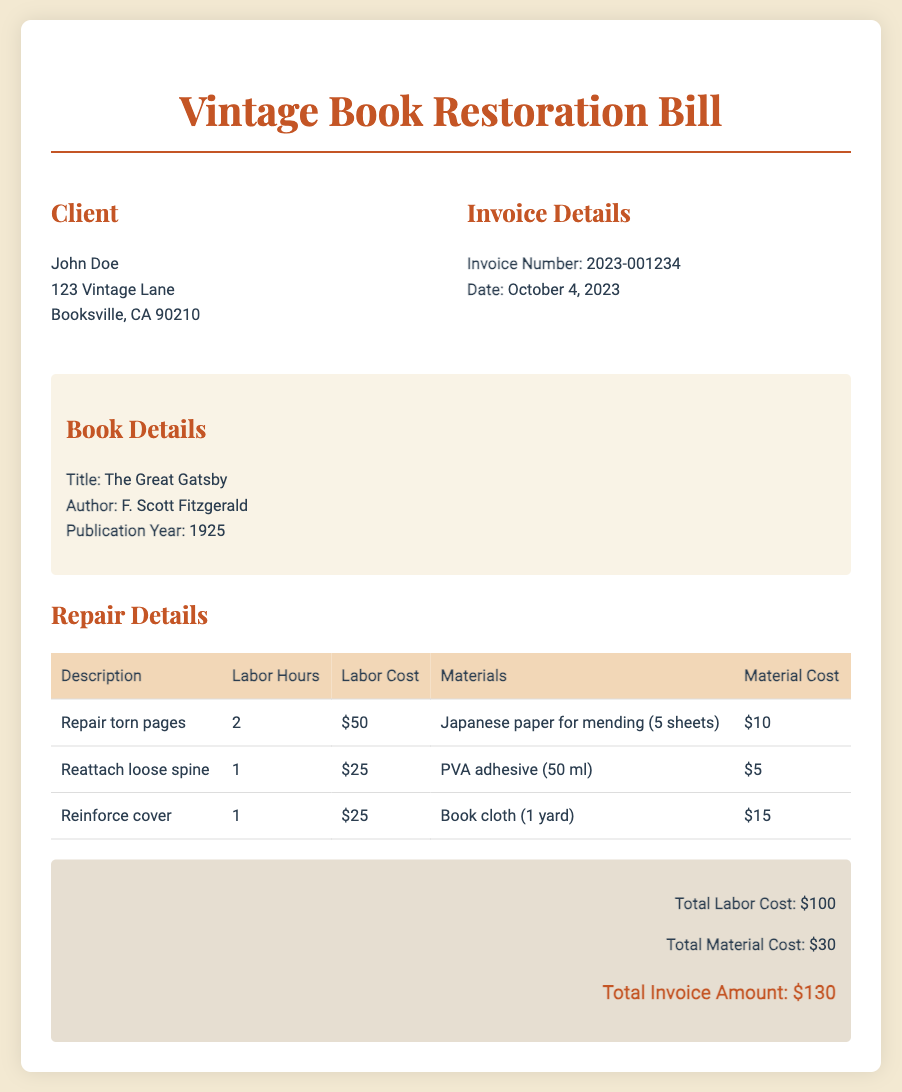What is the client's name? The client's name is provided in the client information section.
Answer: John Doe What is the invoice number? The invoice number can be found under the invoice details section.
Answer: 2023-001234 What is the publication year of the book? The publication year of the book is stated in the book details section.
Answer: 1925 How many labor hours were spent on repairing torn pages? The labor hours for repairing torn pages are listed in the repair details table.
Answer: 2 What is the material cost for reattaching the loose spine? The material cost for reattaching the loose spine is specified in the repair details table.
Answer: $5 What is the total invoice amount? The total invoice amount is calculated from total labor costs and total material costs.
Answer: $130 How many sheets of Japanese paper were used? The number of sheets of Japanese paper used for mending is indicated in the repair details.
Answer: 5 sheets What is the labor cost for reinforcing the cover? The labor cost for reinforcing the cover is mentioned in the repair details table.
Answer: $25 What type of book is being restored? The type of book can be determined from the book details section.
Answer: Novel 